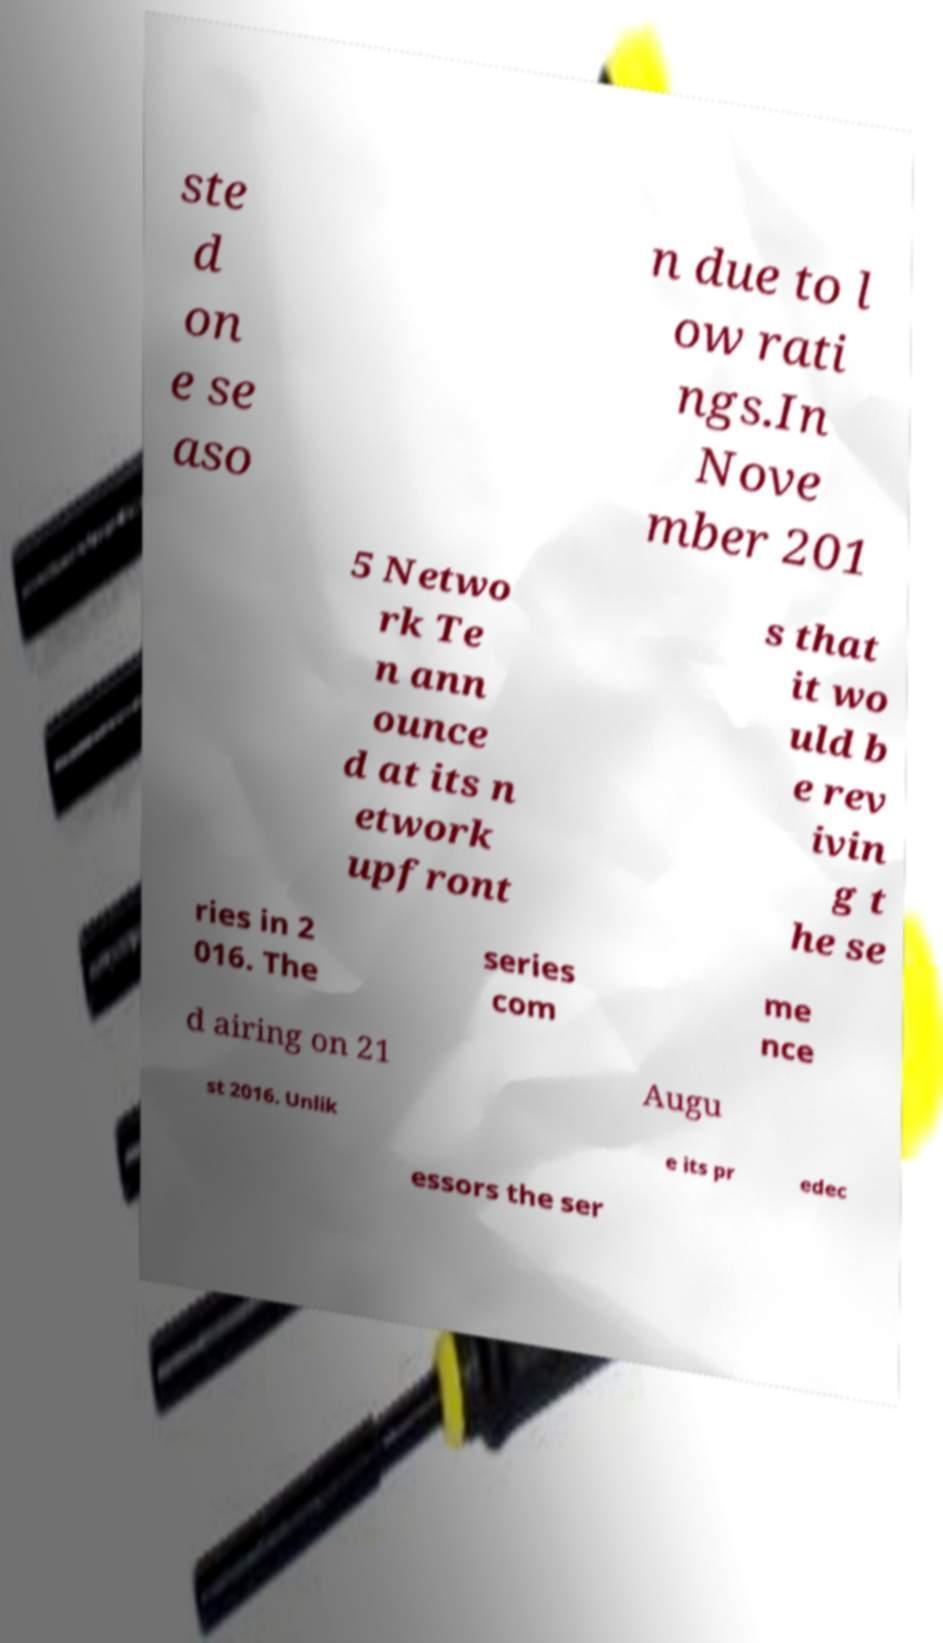Can you read and provide the text displayed in the image?This photo seems to have some interesting text. Can you extract and type it out for me? ste d on e se aso n due to l ow rati ngs.In Nove mber 201 5 Netwo rk Te n ann ounce d at its n etwork upfront s that it wo uld b e rev ivin g t he se ries in 2 016. The series com me nce d airing on 21 Augu st 2016. Unlik e its pr edec essors the ser 